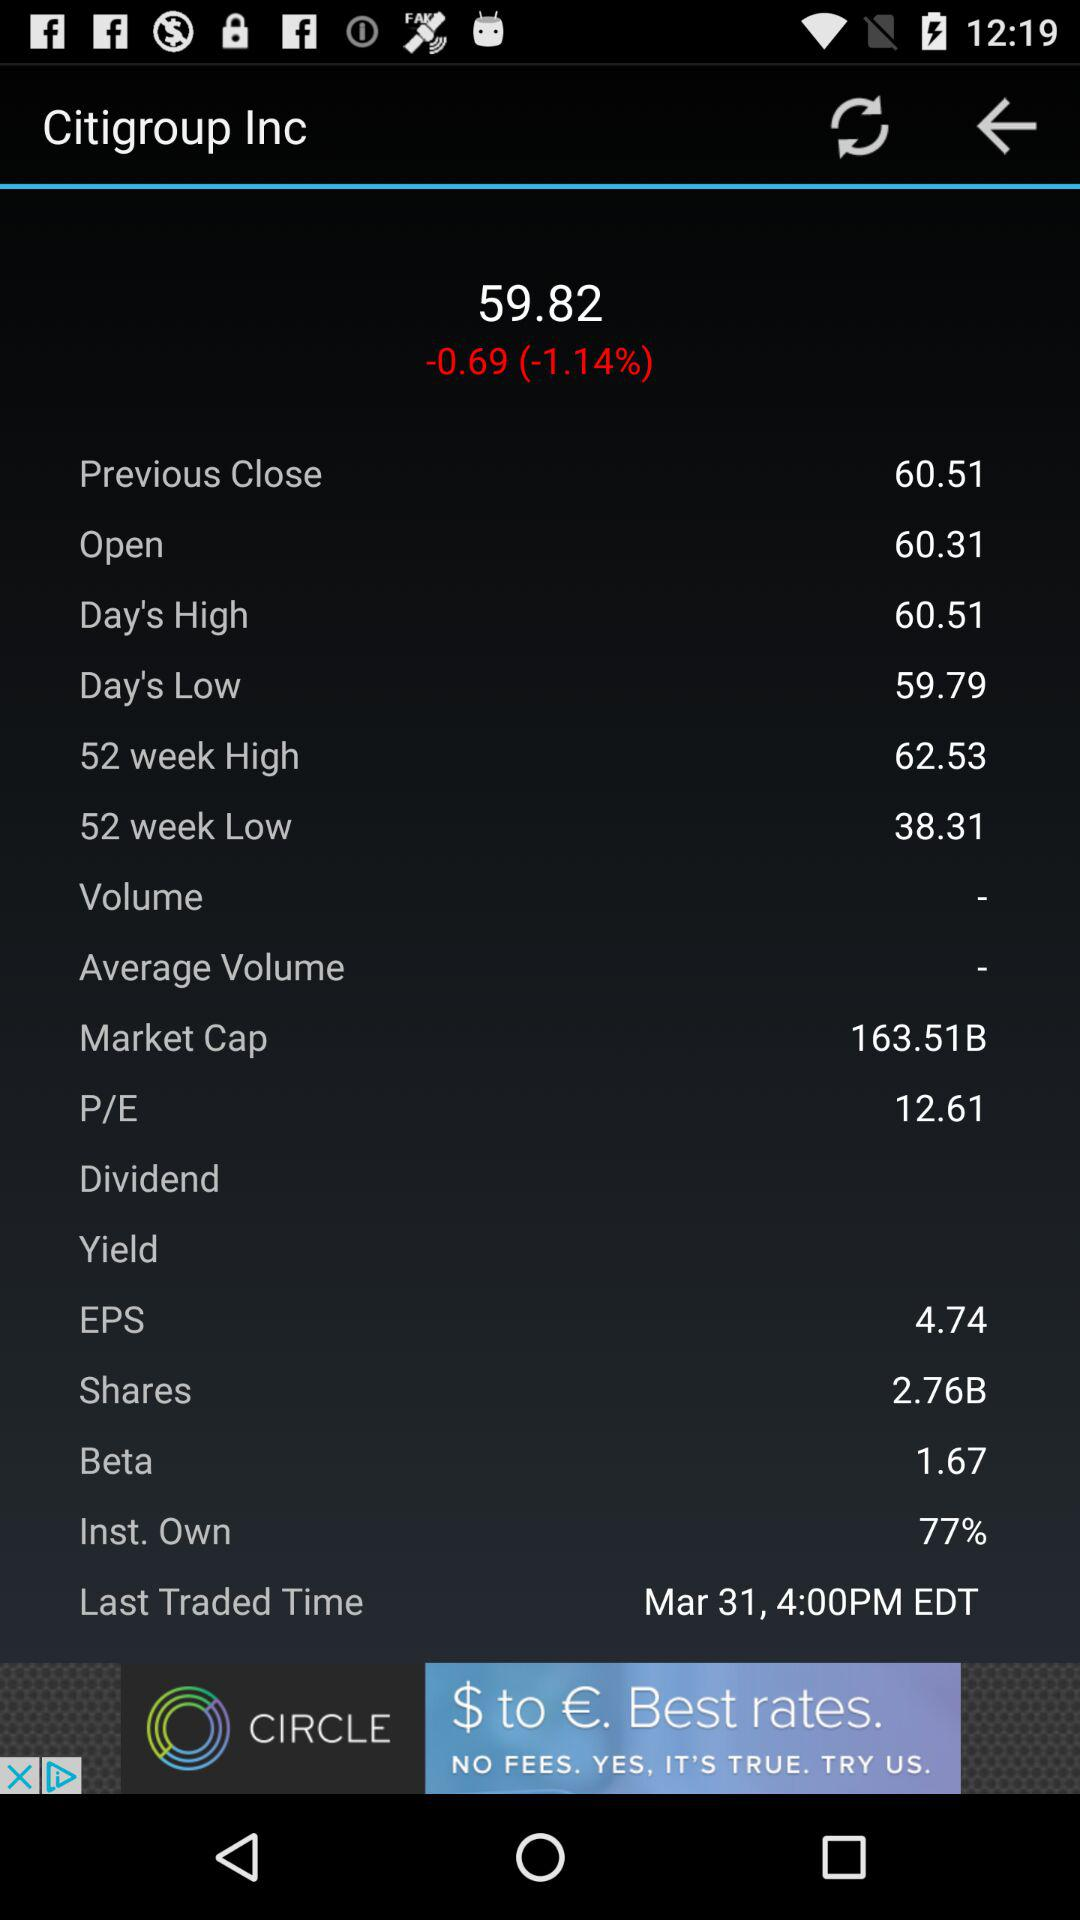What is the last traded time"? The last traded time is 4:00 PM. 